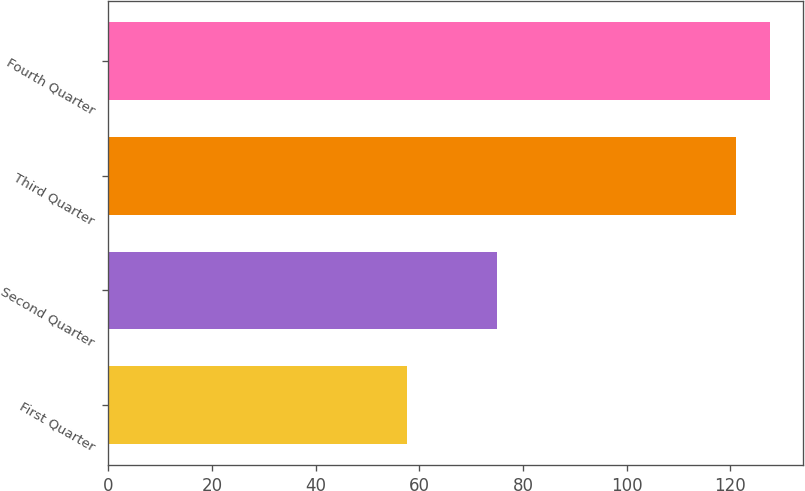<chart> <loc_0><loc_0><loc_500><loc_500><bar_chart><fcel>First Quarter<fcel>Second Quarter<fcel>Third Quarter<fcel>Fourth Quarter<nl><fcel>57.66<fcel>75.03<fcel>121.14<fcel>127.75<nl></chart> 